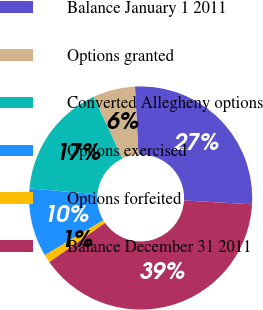Convert chart to OTSL. <chart><loc_0><loc_0><loc_500><loc_500><pie_chart><fcel>Balance January 1 2011<fcel>Options granted<fcel>Converted Allegheny options<fcel>Options exercised<fcel>Options forfeited<fcel>Balance December 31 2011<nl><fcel>26.71%<fcel>6.12%<fcel>16.7%<fcel>9.94%<fcel>1.18%<fcel>39.35%<nl></chart> 